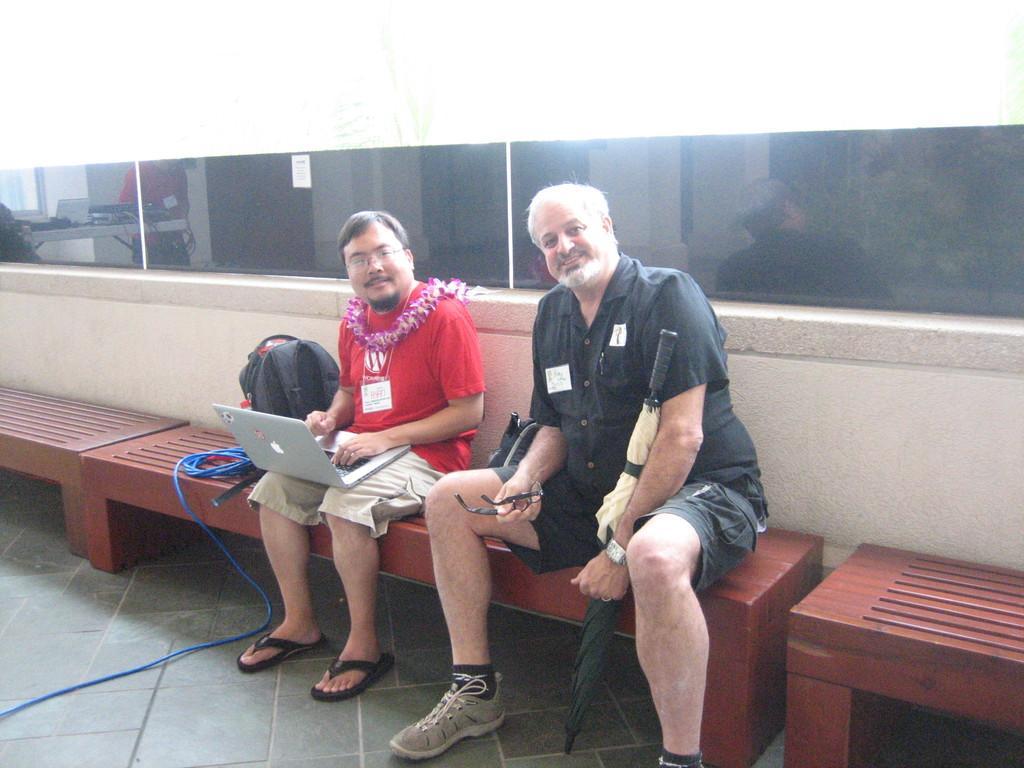Please provide a concise description of this image. In this image there are two people sitting on the bench where one person is holding the umbrella, specs and the other person is holding the laptop. Beside them there is a bag. There is a rope. There are benches. At the bottom of the image there is a floor. Behind them there is a glass wall. 